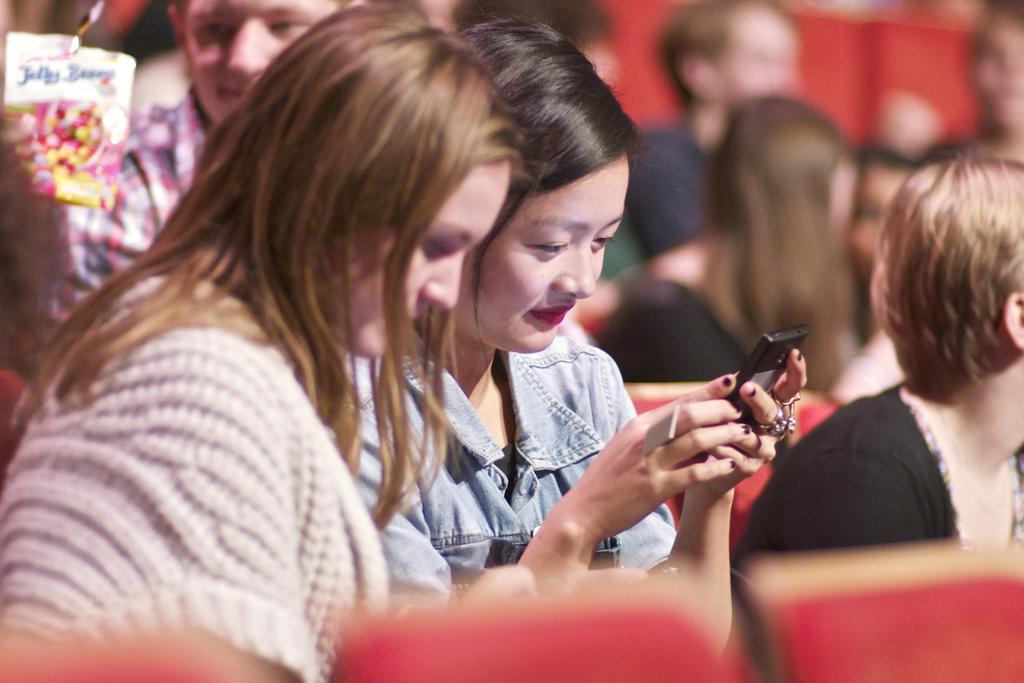What is the main subject of the image? The main subject of the image is a group of people. What are the people in the image doing? The people are sitting on chairs. Can you describe the woman in the middle of the image? The woman in the middle of the image is holding a mobile. How would you describe the background of the image? The background of the image is blurry. What type of business is being conducted on the floor in the image? There is no business or floor present in the image; it features a group of people sitting on chairs with a blurry background. Can you tell me how many tramps are visible in the image? There are no tramps present in the image. 